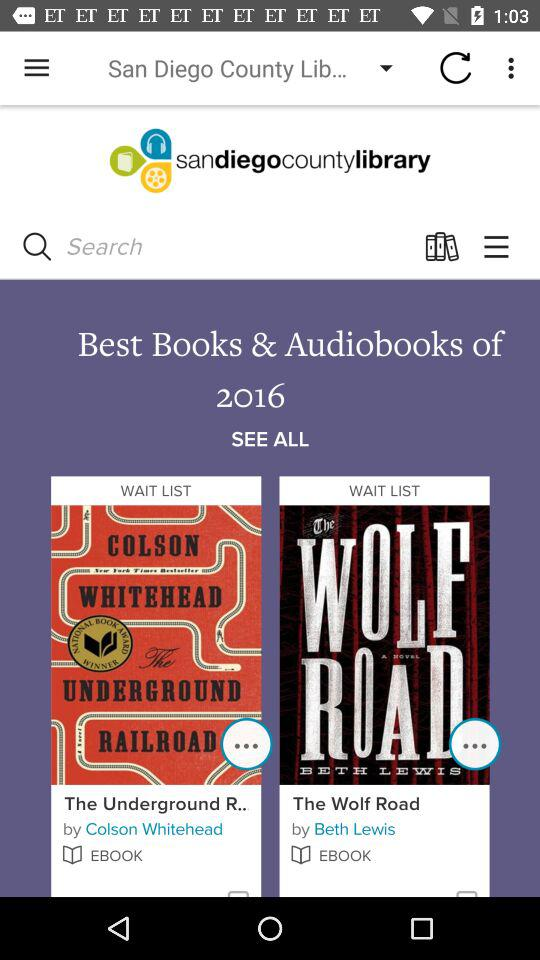What is the read time of "The Wolf Road"?
When the provided information is insufficient, respond with <no answer>. <no answer> 